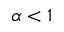<formula> <loc_0><loc_0><loc_500><loc_500>\alpha < 1</formula> 